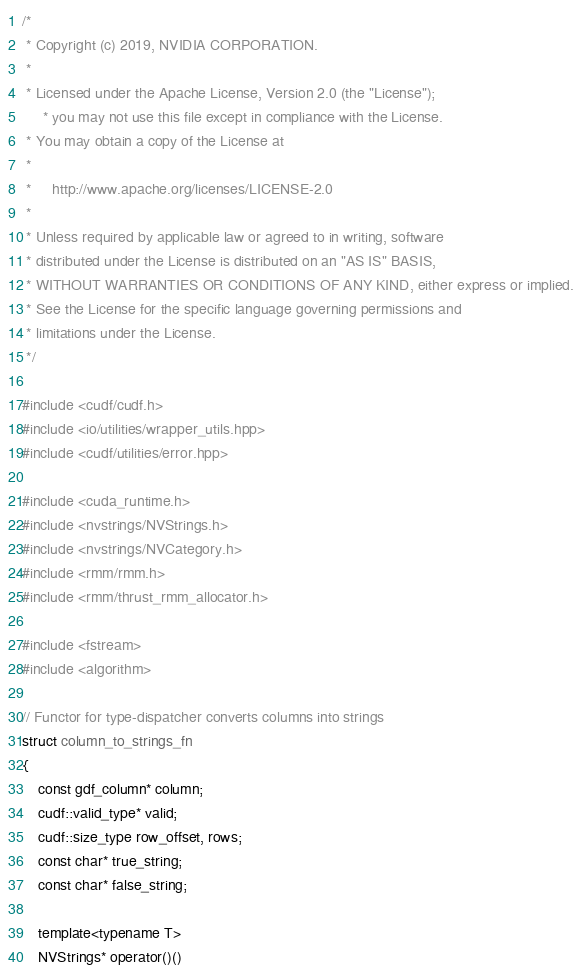<code> <loc_0><loc_0><loc_500><loc_500><_Cuda_>/*
 * Copyright (c) 2019, NVIDIA CORPORATION.
 *
 * Licensed under the Apache License, Version 2.0 (the "License");
     * you may not use this file except in compliance with the License.
 * You may obtain a copy of the License at
 *
 *     http://www.apache.org/licenses/LICENSE-2.0
 *
 * Unless required by applicable law or agreed to in writing, software
 * distributed under the License is distributed on an "AS IS" BASIS,
 * WITHOUT WARRANTIES OR CONDITIONS OF ANY KIND, either express or implied.
 * See the License for the specific language governing permissions and
 * limitations under the License.
 */

#include <cudf/cudf.h>
#include <io/utilities/wrapper_utils.hpp>
#include <cudf/utilities/error.hpp>

#include <cuda_runtime.h>
#include <nvstrings/NVStrings.h>
#include <nvstrings/NVCategory.h>
#include <rmm/rmm.h>
#include <rmm/thrust_rmm_allocator.h>

#include <fstream>
#include <algorithm>

// Functor for type-dispatcher converts columns into strings
struct column_to_strings_fn
{
    const gdf_column* column;
    cudf::valid_type* valid;
    cudf::size_type row_offset, rows;
    const char* true_string;
    const char* false_string;

    template<typename T>
    NVStrings* operator()()</code> 